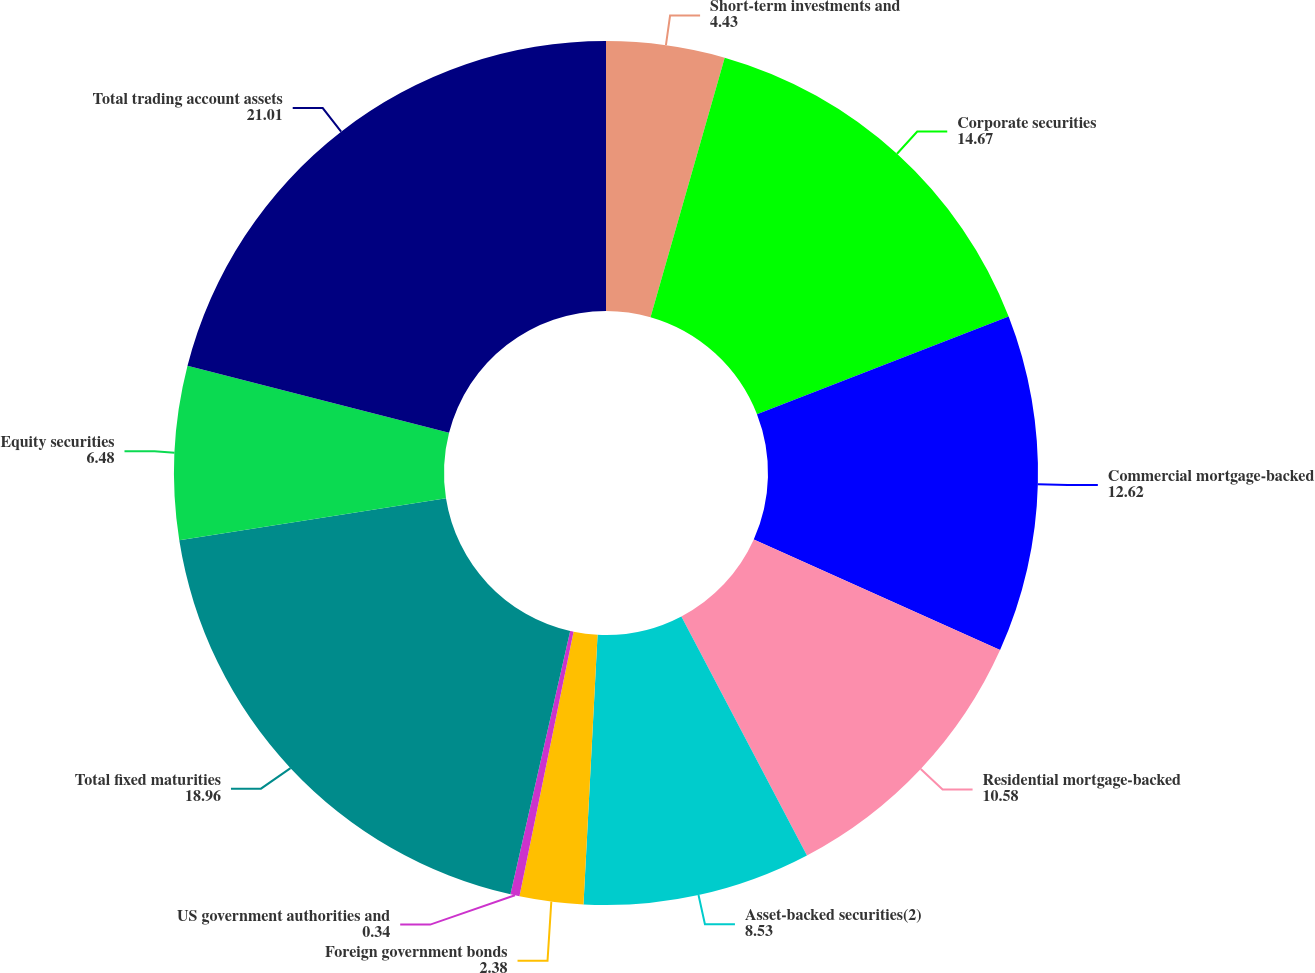<chart> <loc_0><loc_0><loc_500><loc_500><pie_chart><fcel>Short-term investments and<fcel>Corporate securities<fcel>Commercial mortgage-backed<fcel>Residential mortgage-backed<fcel>Asset-backed securities(2)<fcel>Foreign government bonds<fcel>US government authorities and<fcel>Total fixed maturities<fcel>Equity securities<fcel>Total trading account assets<nl><fcel>4.43%<fcel>14.67%<fcel>12.62%<fcel>10.58%<fcel>8.53%<fcel>2.38%<fcel>0.34%<fcel>18.96%<fcel>6.48%<fcel>21.01%<nl></chart> 